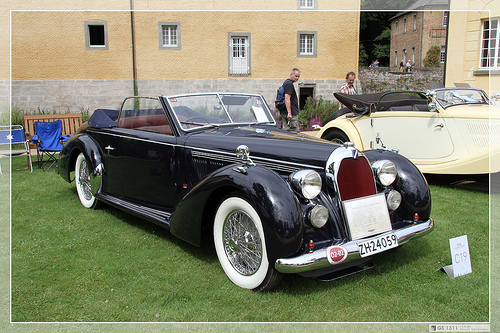<image>
Is there a man behind the car? Yes. From this viewpoint, the man is positioned behind the car, with the car partially or fully occluding the man. Is the bench behind the chair? Yes. From this viewpoint, the bench is positioned behind the chair, with the chair partially or fully occluding the bench. 